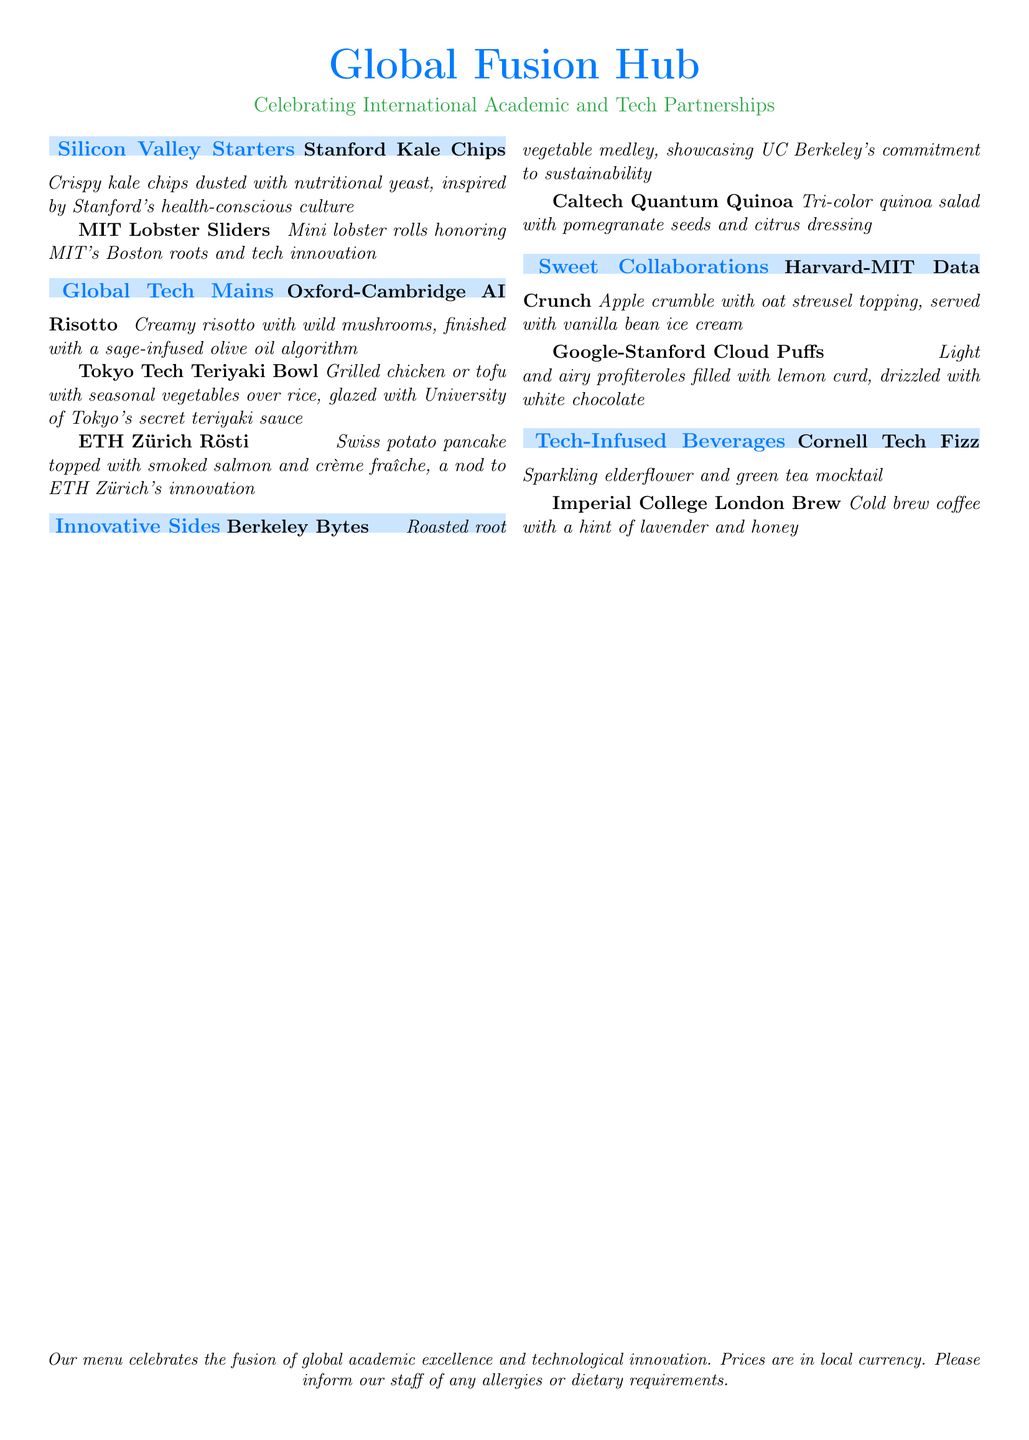What is the name of the restaurant? The name of the restaurant is prominently displayed at the top of the document.
Answer: Global Fusion Hub What are the prices listed in? The document indicates that prices are presented to customers in a specific format.
Answer: Local currency What dish celebrates MIT's Boston roots? The dish mentioned in the starter section that relates to MIT's location is specified in the document.
Answer: MIT Lobster Sliders Which beverage includes elderflower? The drink that features elderflower is named in the beverage section of the menu.
Answer: Cornell Tech Fizz How many dessert options are available? The document lists a total of two dessert items under the Sweet Collaborations section.
Answer: Two What vegetable medley is showcased by UC Berkeley? The side dish mentioned as representing a commitment to sustainability is detailed in the sides section.
Answer: Berkeley Bytes What is the main ingredient in the Oxford-Cambridge AI Risotto? The main component of the risotto is described clearly in the document.
Answer: Wild mushrooms What type of quinoa is used in the Caltech dish? The salad's attributes and its quinoa variety are highlighted in the menu.
Answer: Tri-color What flour-based dessert features lemon curd? The dessert that includes lemon curd and is light and airy is specified in Sweet Collaborations.
Answer: Google-Stanford Cloud Puffs 